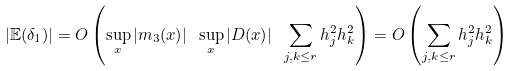Convert formula to latex. <formula><loc_0><loc_0><loc_500><loc_500>| \mathbb { E } ( \delta _ { 1 } ) | = O \left ( \sup _ { x } | m _ { 3 } ( x ) | \ \sup _ { x } | D ( x ) | \ \sum _ { j , k \leq r } h _ { j } ^ { 2 } h _ { k } ^ { 2 } \right ) = O \left ( \sum _ { j , k \leq r } h _ { j } ^ { 2 } h _ { k } ^ { 2 } \right )</formula> 